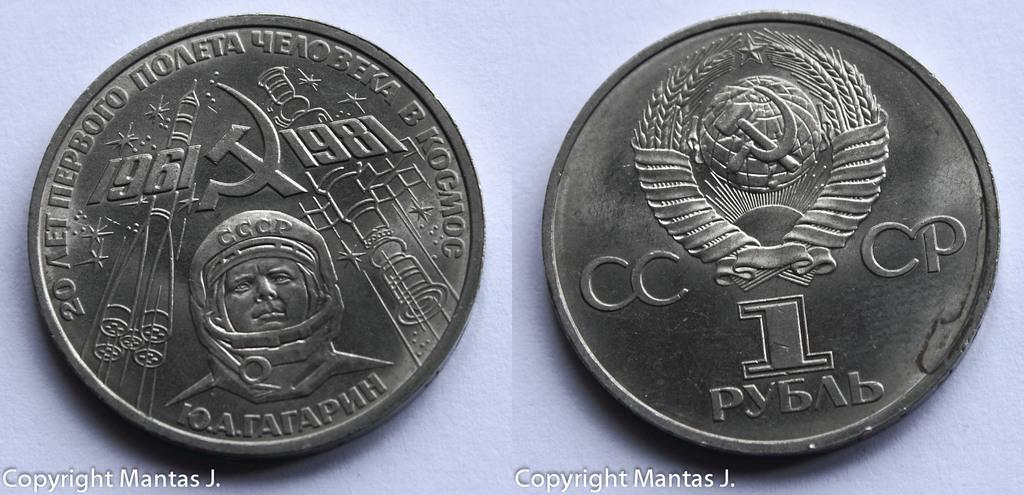What is the letter under the 1?
Offer a terse response. B. 